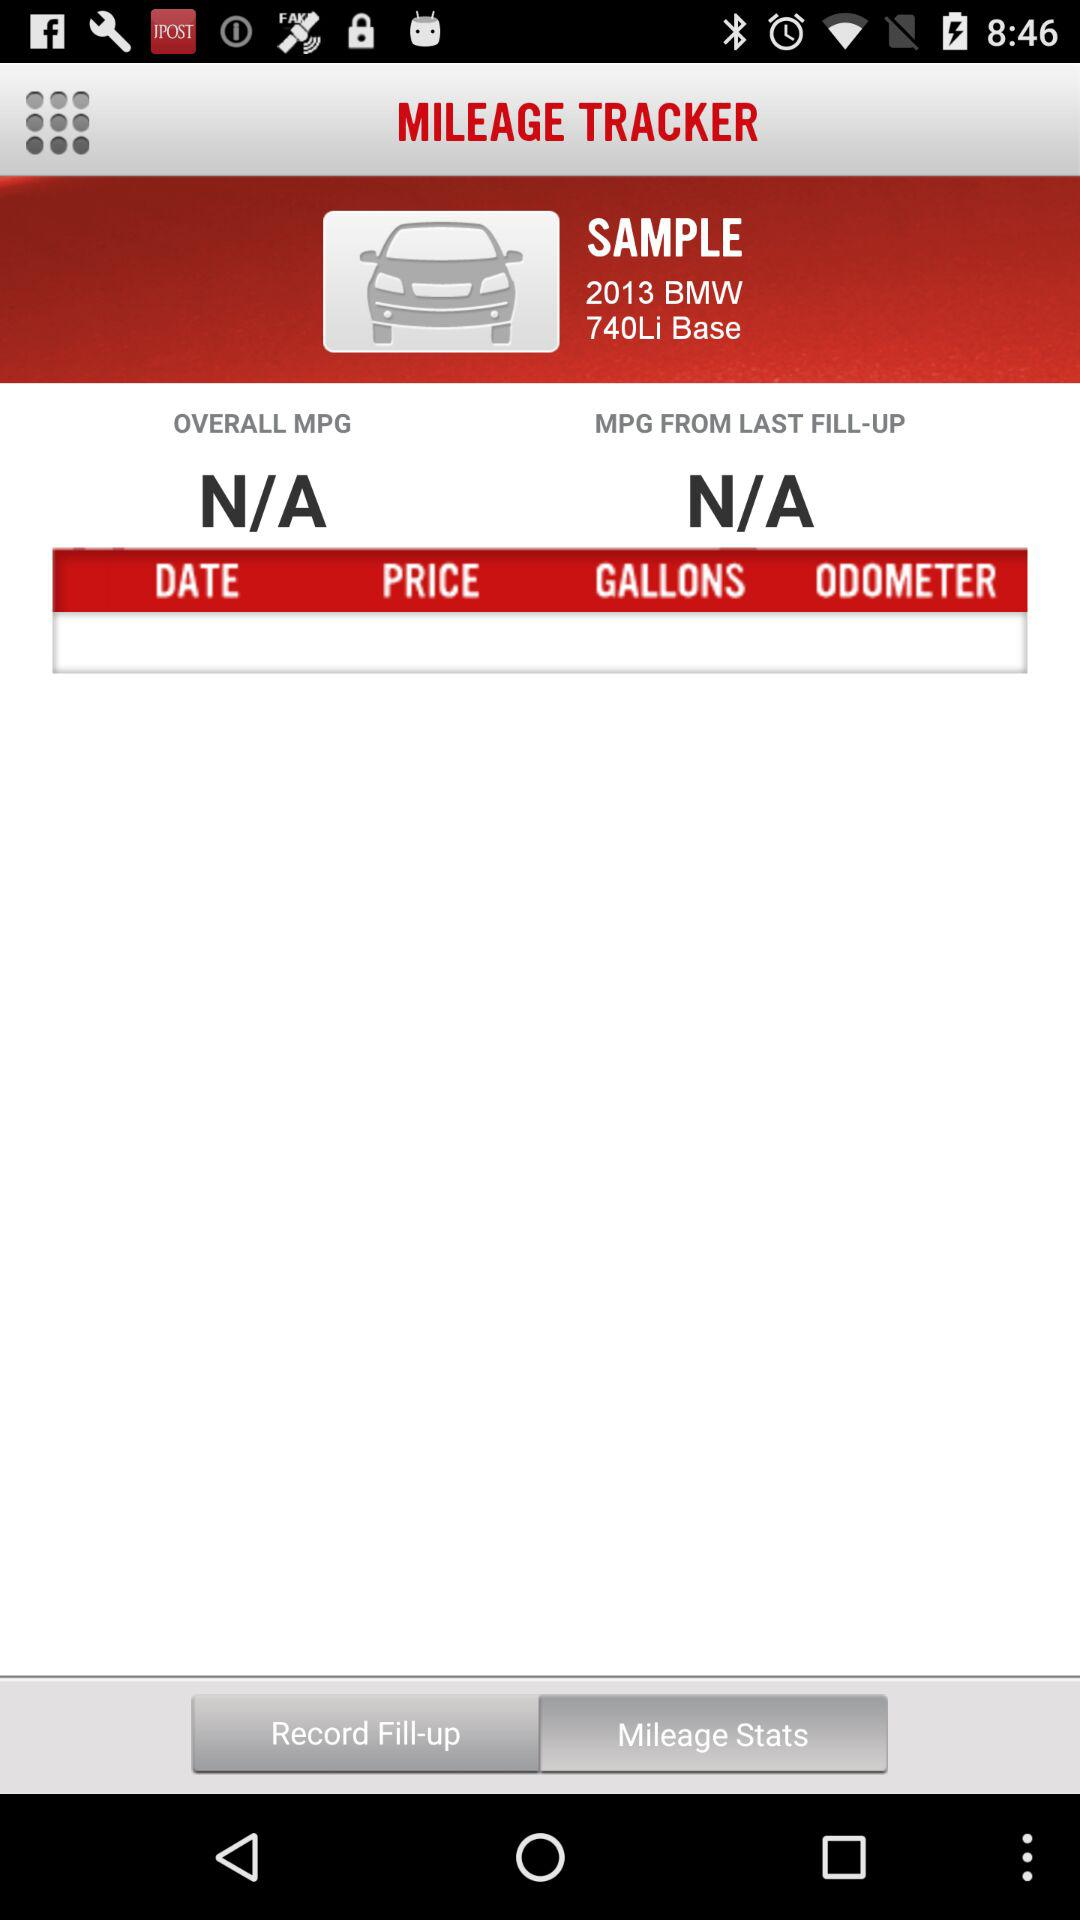What is the name of the application? The name of the application is "MILEAGE TRACKER". 